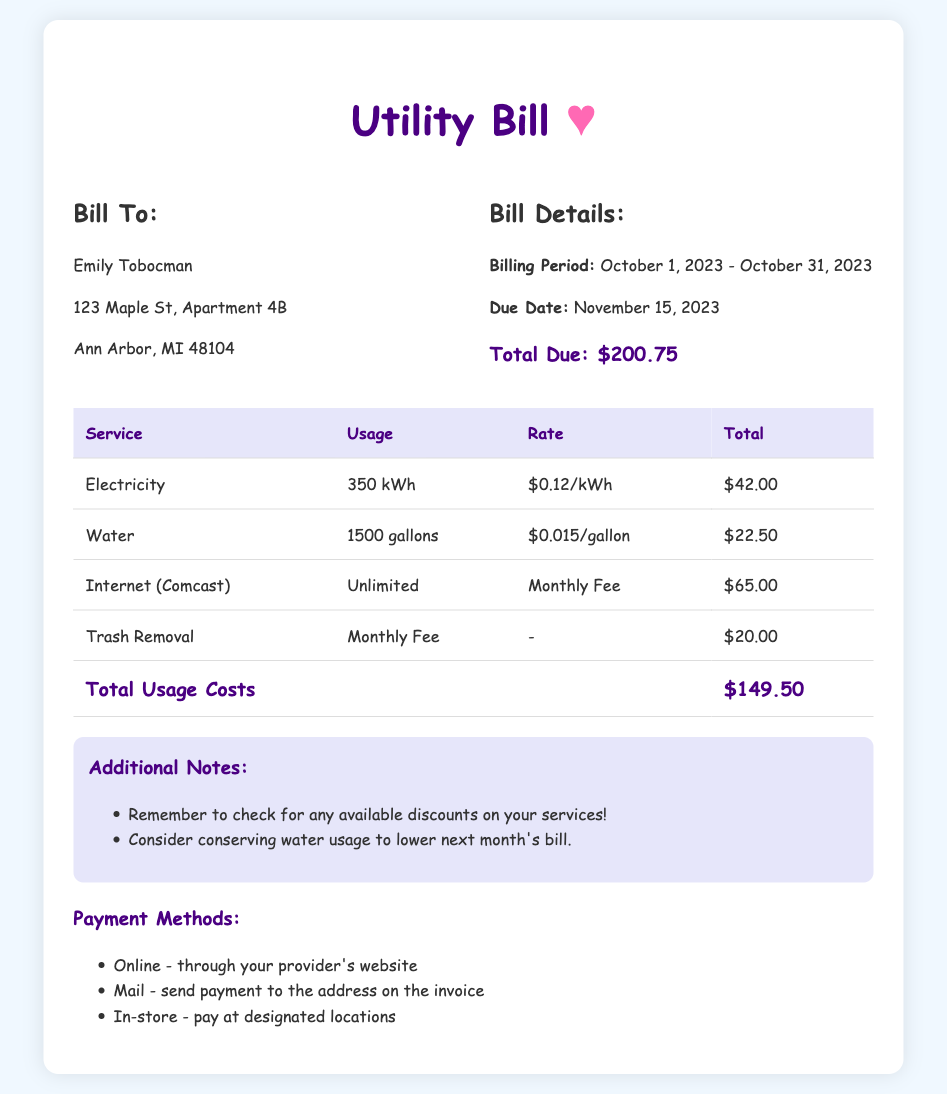what is the billing period? The billing period is specified as the time range for the services being billed, from October 1, 2023 to October 31, 2023.
Answer: October 1, 2023 - October 31, 2023 who is the bill addressed to? The document specifies the name of the person to whom the bill is being sent, which is Emily Tobocman.
Answer: Emily Tobocman what is the total due amount? The total due amount is highlighted in the bill and represents the final amount to be paid, which is $200.75.
Answer: $200.75 how much was spent on electricity? The bill provides a breakdown of costs for each service, with electricity having a total charge of $42.00.
Answer: $42.00 what was the water usage in gallons? The bill specifies that the water usage for the billing period was measured in gallons, which is 1500 gallons.
Answer: 1500 gallons how much is charged for Internet service? The document indicates a flat fee for Internet service, which is stated as $65.00.
Answer: $65.00 what additional cost is included for trash removal? The bill lists trash removal as a separate service with a monthly fee that is charged, which is $20.00.
Answer: $20.00 what is the reminder in the additional notes? The additional notes section includes reminders pertaining to discounts and conservation strategies, which encourage conserving water to lower the bill.
Answer: Consider conserving water usage to lower next month's bill what payment methods are accepted? The document outlines a few different ways that the payment can be made, which are online, mail, and in-store.
Answer: Online, Mail, In-store 